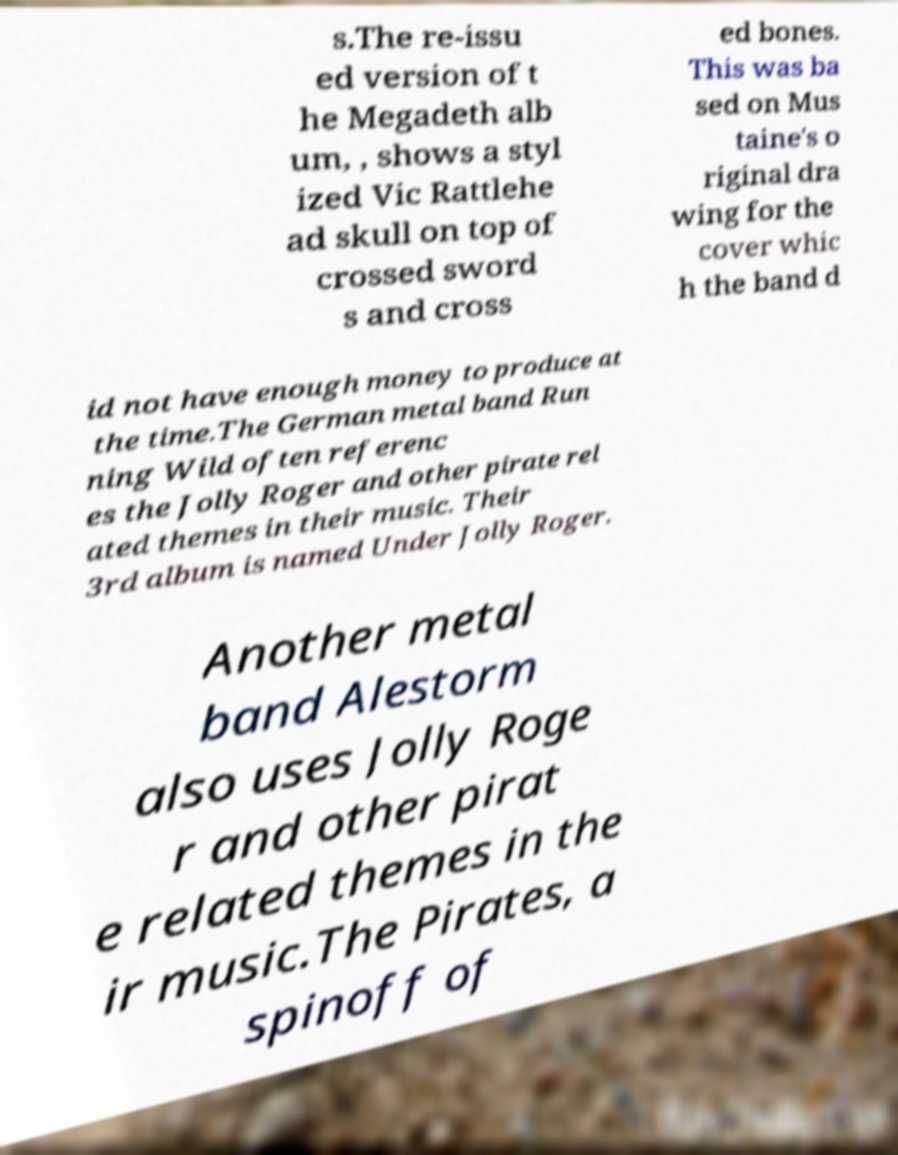There's text embedded in this image that I need extracted. Can you transcribe it verbatim? s.The re-issu ed version of t he Megadeth alb um, , shows a styl ized Vic Rattlehe ad skull on top of crossed sword s and cross ed bones. This was ba sed on Mus taine's o riginal dra wing for the cover whic h the band d id not have enough money to produce at the time.The German metal band Run ning Wild often referenc es the Jolly Roger and other pirate rel ated themes in their music. Their 3rd album is named Under Jolly Roger. Another metal band Alestorm also uses Jolly Roge r and other pirat e related themes in the ir music.The Pirates, a spinoff of 